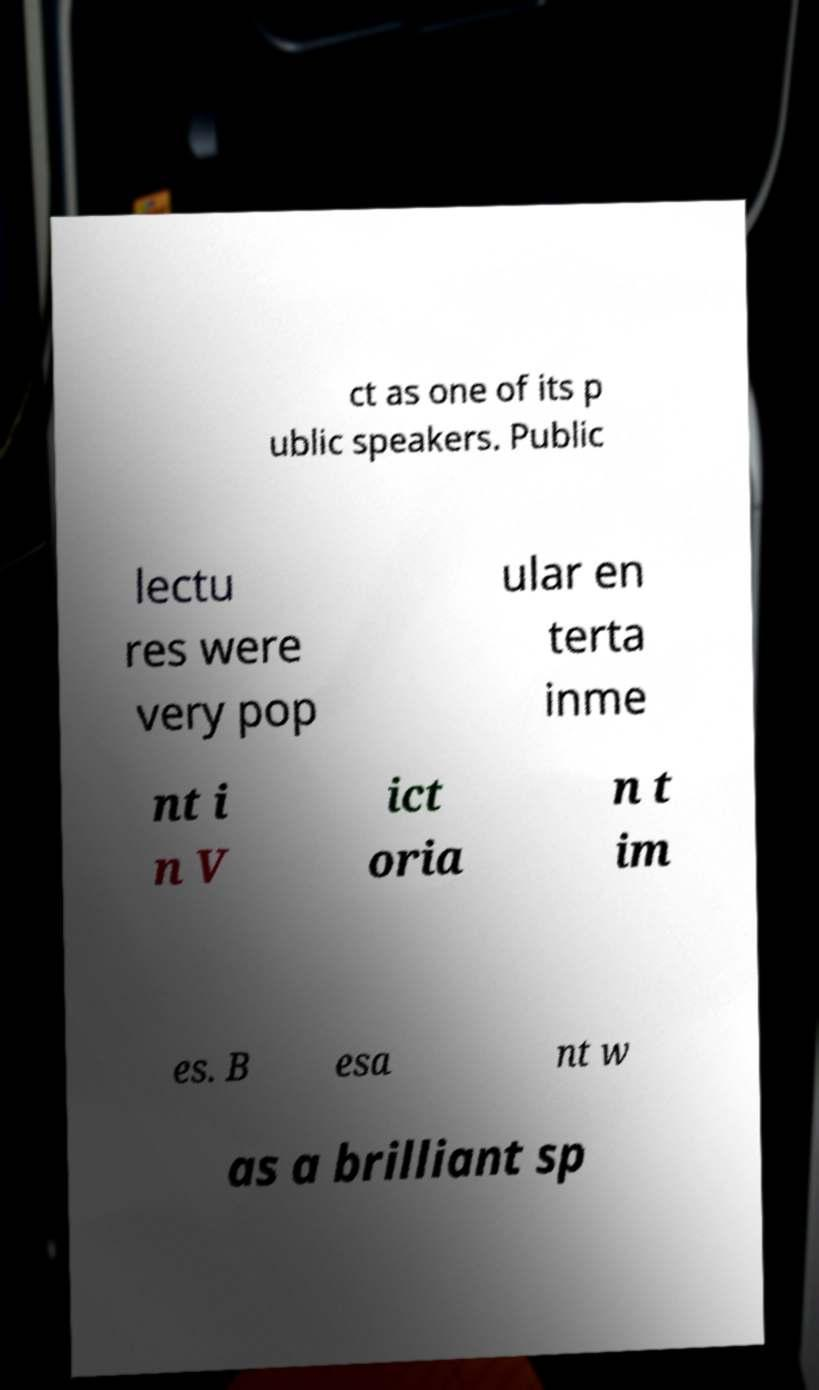Please read and relay the text visible in this image. What does it say? ct as one of its p ublic speakers. Public lectu res were very pop ular en terta inme nt i n V ict oria n t im es. B esa nt w as a brilliant sp 